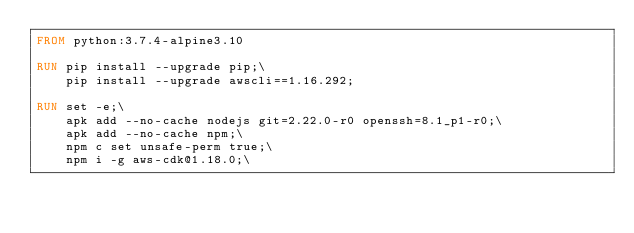Convert code to text. <code><loc_0><loc_0><loc_500><loc_500><_Dockerfile_>FROM python:3.7.4-alpine3.10

RUN pip install --upgrade pip;\
    pip install --upgrade awscli==1.16.292;

RUN set -e;\
    apk add --no-cache nodejs git=2.22.0-r0 openssh=8.1_p1-r0;\
    apk add --no-cache npm;\
    npm c set unsafe-perm true;\
    npm i -g aws-cdk@1.18.0;\
</code> 